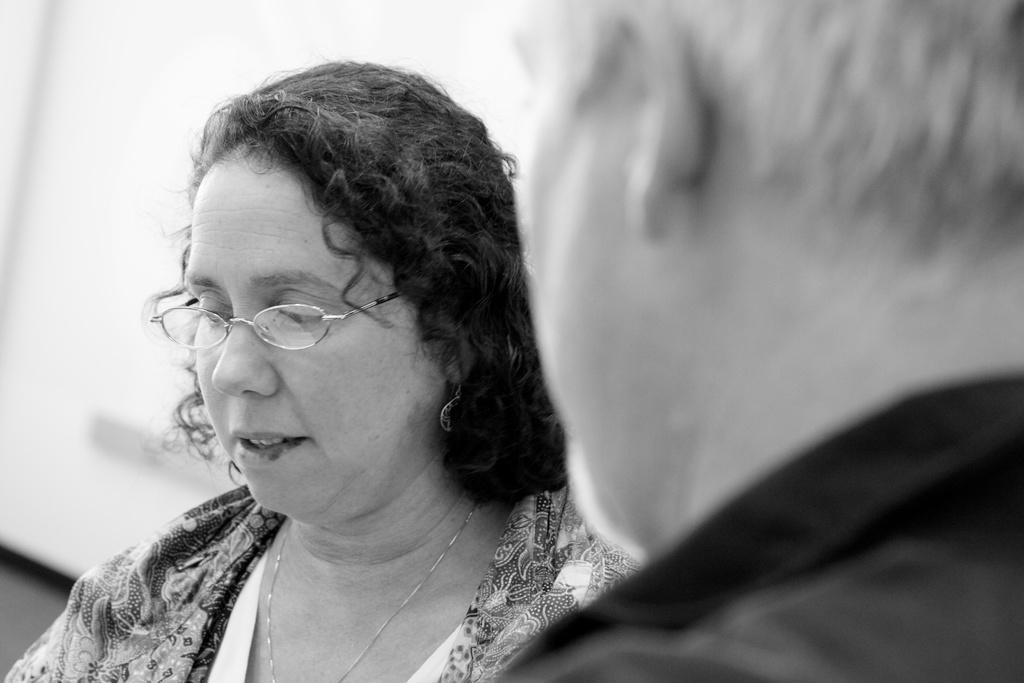Describe this image in one or two sentences. This is black and white image, in this image there is a man and a woman. 